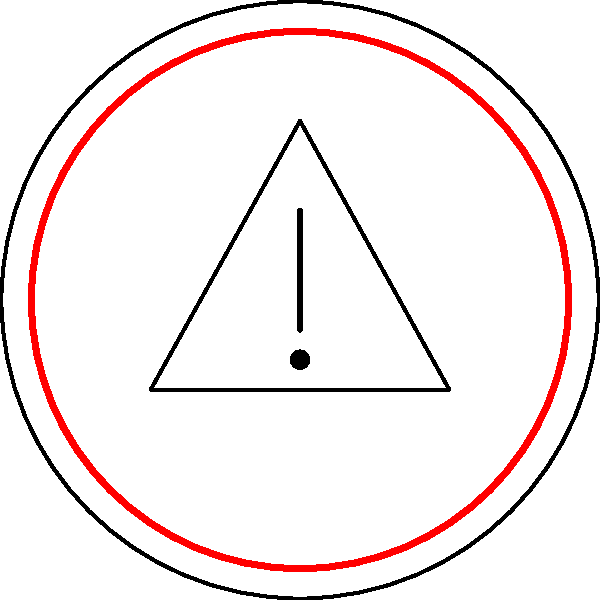As a tourism student, you encounter the road sign shown above during an international trip. What does this sign typically indicate to travelers? To interpret this international road sign, let's break it down step-by-step:

1. Shape: The sign is circular, which generally indicates a mandatory action or prohibition in many countries.

2. Color scheme: 
   - White background: This is common for regulatory signs.
   - Red border: Red often signifies danger, prohibition, or a critical message.

3. Symbol:
   - Triangle: An upward-pointing triangle is a universal symbol for caution or warning.
   - Exclamation mark: This punctuation mark emphasizes importance or urgency.

4. Overall composition: The combination of a red-bordered circle with a warning triangle inside is a standardized design used in many countries, especially in Europe.

5. Meaning in road sign systems: This specific configuration is internationally recognized as a "General Warning" or "Other Dangers" sign.

6. Traveler interpretation: For tourists and international travelers, this sign indicates that they should be extra cautious and alert for potential hazards that may not be explicitly specified by other signs.

Given these elements and your background in tourism studies, you should recognize this as a general warning sign used to alert travelers to potential dangers or unusual conditions ahead.
Answer: General Warning or Other Dangers ahead 